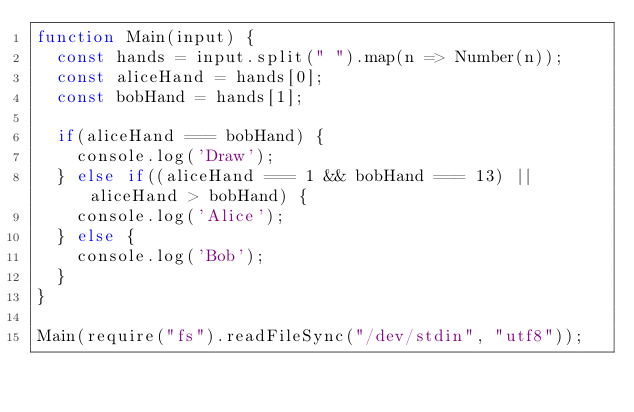Convert code to text. <code><loc_0><loc_0><loc_500><loc_500><_JavaScript_>function Main(input) {
	const hands = input.split(" ").map(n => Number(n));
  const aliceHand = hands[0];
  const bobHand = hands[1];

  if(aliceHand === bobHand) {
    console.log('Draw');
  } else if((aliceHand === 1 && bobHand === 13) || aliceHand > bobHand) {
    console.log('Alice');
  } else {
    console.log('Bob');
  }
}

Main(require("fs").readFileSync("/dev/stdin", "utf8"));</code> 